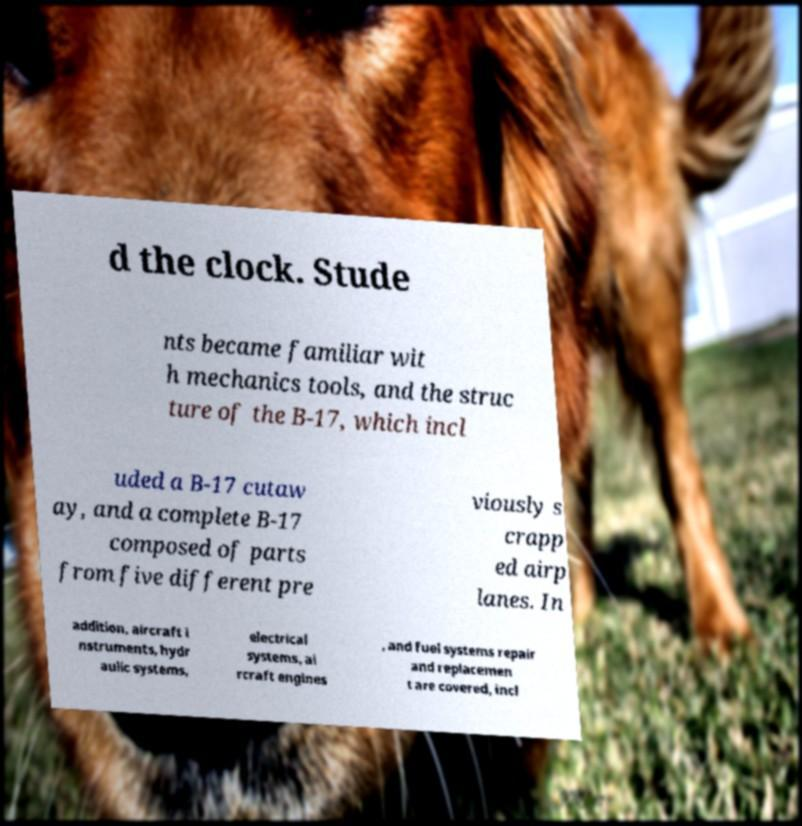Could you extract and type out the text from this image? d the clock. Stude nts became familiar wit h mechanics tools, and the struc ture of the B-17, which incl uded a B-17 cutaw ay, and a complete B-17 composed of parts from five different pre viously s crapp ed airp lanes. In addition, aircraft i nstruments, hydr aulic systems, electrical systems, ai rcraft engines , and fuel systems repair and replacemen t are covered, incl 